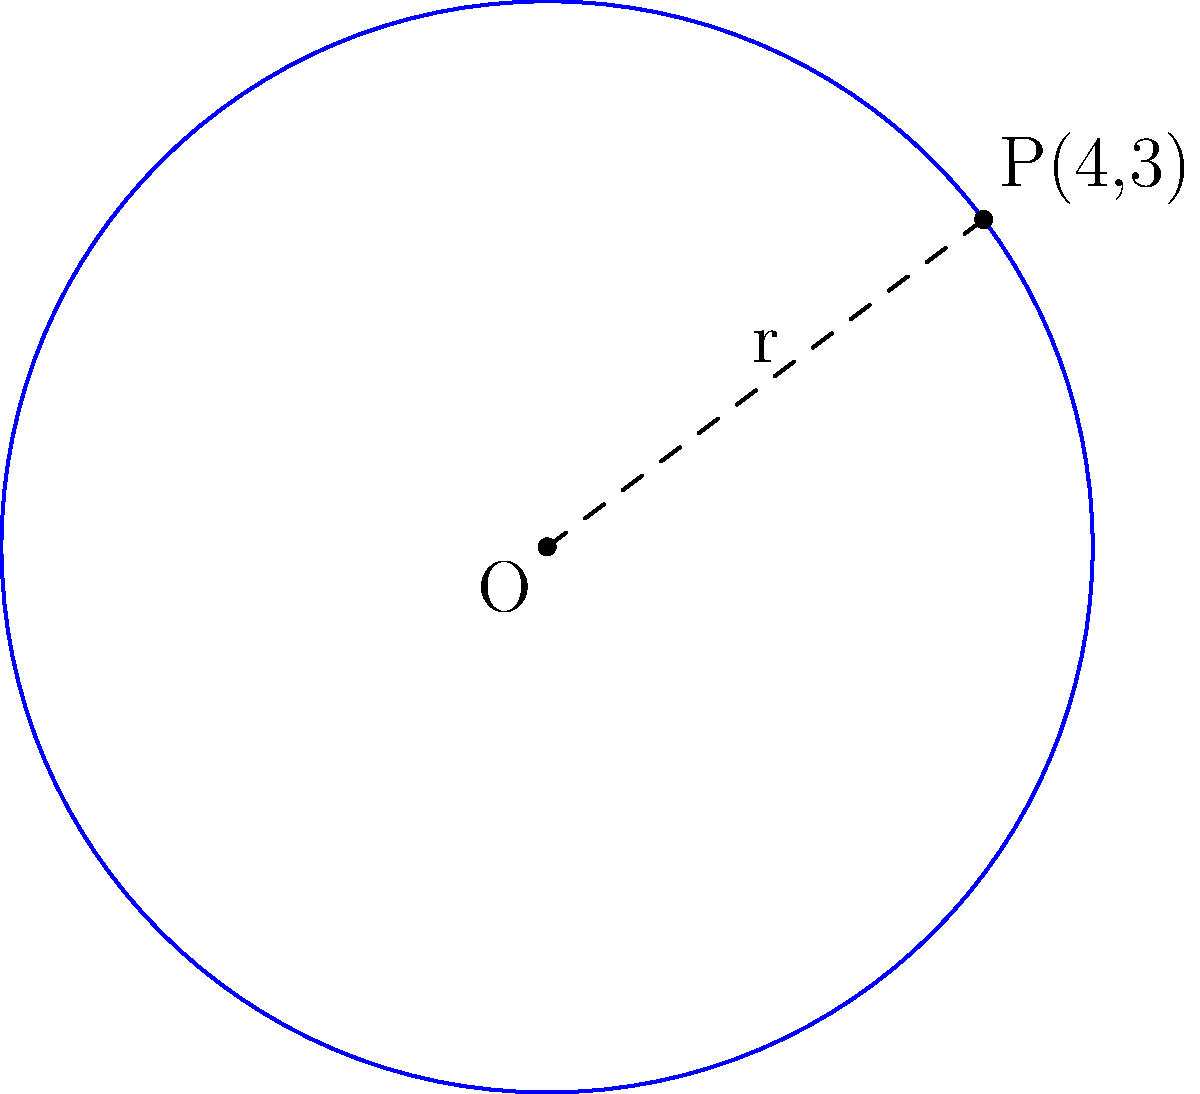As an endocrinologist, you often use circular models to represent hormone receptor sites. Given a circular receptor with its center at the origin (0,0) and a point P(4,3) on its circumference, calculate the area of this receptor site. Round your answer to two decimal places. To find the area of the circle, we need to follow these steps:

1) First, we need to find the radius of the circle. We can do this by calculating the distance between the center (0,0) and the point P(4,3) on the circumference.

2) The distance formula is:
   $$r = \sqrt{(x_2-x_1)^2 + (y_2-y_1)^2}$$

3) Plugging in our values:
   $$r = \sqrt{(4-0)^2 + (3-0)^2} = \sqrt{16 + 9} = \sqrt{25} = 5$$

4) Now that we have the radius, we can use the formula for the area of a circle:
   $$A = \pi r^2$$

5) Substituting our radius:
   $$A = \pi (5)^2 = 25\pi$$

6) Using 3.14 as an approximation for π:
   $$A \approx 25 * 3.14 = 78.5$$

7) Rounding to two decimal places:
   $$A \approx 78.50$$

This area could represent the total surface area of hormone receptor sites in a given tissue sample, which is crucial for understanding hormone-tissue interactions in endocrinology.
Answer: $78.50$ square units 